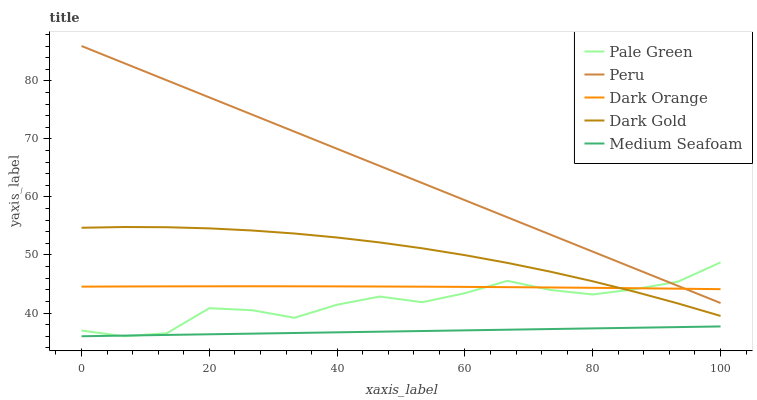Does Pale Green have the minimum area under the curve?
Answer yes or no. No. Does Pale Green have the maximum area under the curve?
Answer yes or no. No. Is Pale Green the smoothest?
Answer yes or no. No. Is Medium Seafoam the roughest?
Answer yes or no. No. Does Peru have the lowest value?
Answer yes or no. No. Does Pale Green have the highest value?
Answer yes or no. No. Is Medium Seafoam less than Dark Orange?
Answer yes or no. Yes. Is Dark Orange greater than Medium Seafoam?
Answer yes or no. Yes. Does Medium Seafoam intersect Dark Orange?
Answer yes or no. No. 